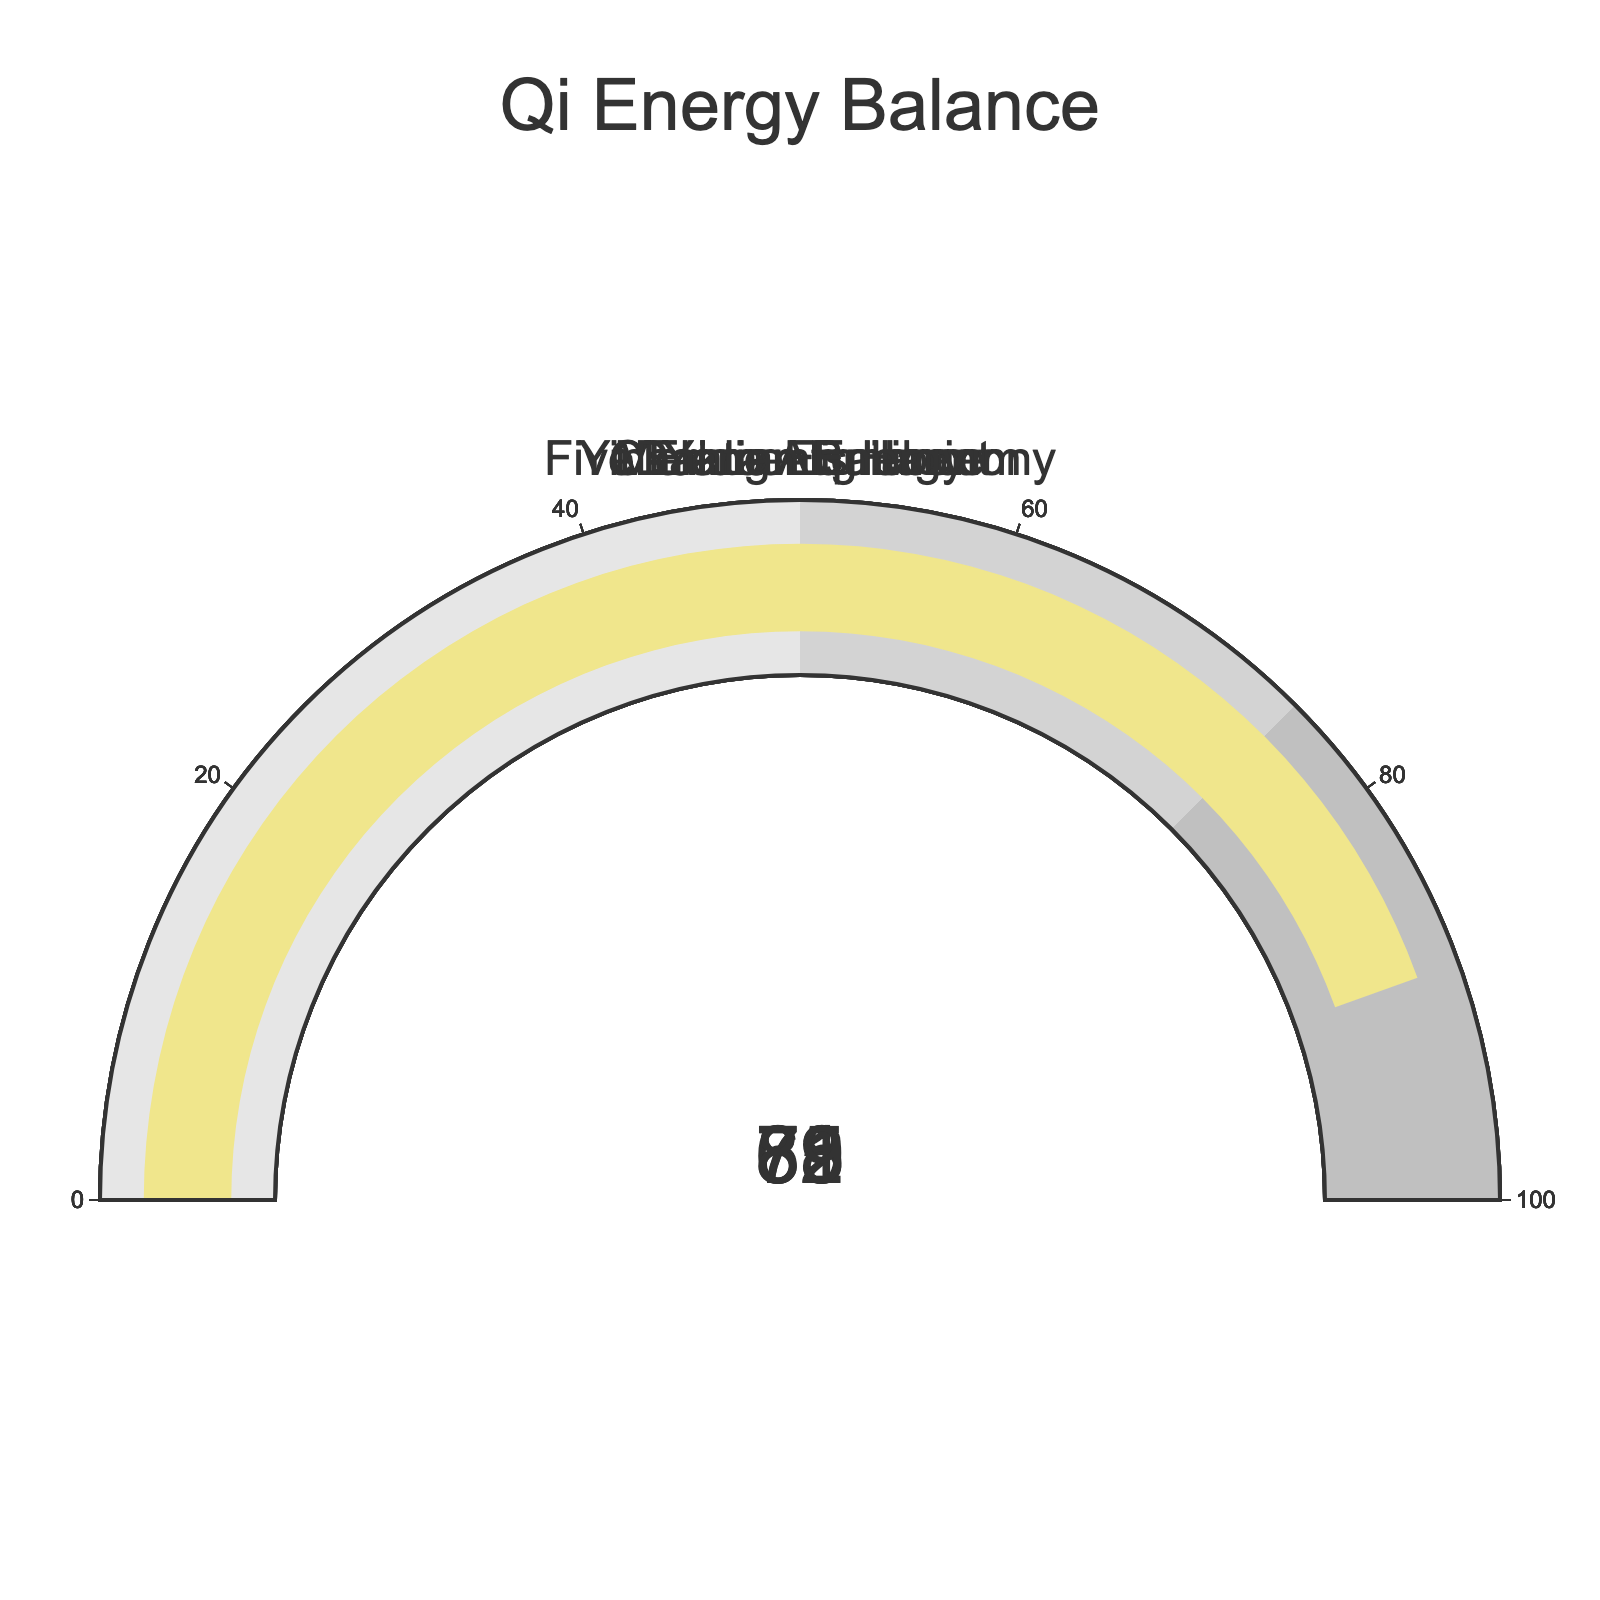What's the highest value displayed on the gauges? The highest value can be found by examining the values on each gauge. They are 78, 65, 82, 71, and 89. The highest value among these is 89.
Answer: 89 Which gauge represents the Dantian Energy? By observing the gauge titles next to the corresponding values, the Dantian Energy gauge shows a value of 89.
Answer: The gauge with value 89 What's the average value of all the gauges? Summing up all the values (78 + 65 + 82 + 71 + 89) equals 385. There are 5 categories, so the average is 385/5 = 77.
Answer: 77 Which gauge has the lowest value? To find the lowest value, look for the smallest number among the gauges. The values are 78, 65, 82, 71, and 89, with the lowest being 65.
Answer: Chakra Alignment Is the Yin-Yang Equilibrium value higher or lower than the Five Elements Harmony value? Comparing the values, Yin-Yang Equilibrium is 71 and Five Elements Harmony is 82. Since 71 is less than 82, the Yin-Yang Equilibrium value is lower.
Answer: Lower than Five Elements Harmony What is the sum of the Meridian Balance and Chakra Alignment values? Adding the values of Meridian Balance (78) and Chakra Alignment (65) gives 78 + 65 = 143.
Answer: 143 Which is closer to complete balance: Five Elements Harmony or Yin-Yang Equilibrium? Complete balance is represented by 100. Five Elements Harmony has a value of 82 and Yin-Yang Equilibrium has a value of 71. The difference from 100 for Five Elements Harmony is 18, and for Yin-Yang Equilibrium is 29. Since 18 is closer than 29, Five Elements Harmony is closer to complete balance.
Answer: Five Elements Harmony How much higher is the Dantian Energy value than the Meridian Balance value? The Dantian Energy value is 89, and the Meridian Balance value is 78. The difference is 89 - 78 = 11.
Answer: 11 What's the median value of the five gauges? Arranging the values in ascending order: 65, 71, 78, 82, 89, the median is the middle value, which is 78.
Answer: 78 Is the Chakra Alignment gauge past the halfway point on the gauge scale? The halfway point on the gauge scale is 50, and the Chakra Alignment value is 65, which is greater than 50, indicating it's past the halfway point.
Answer: Yes 